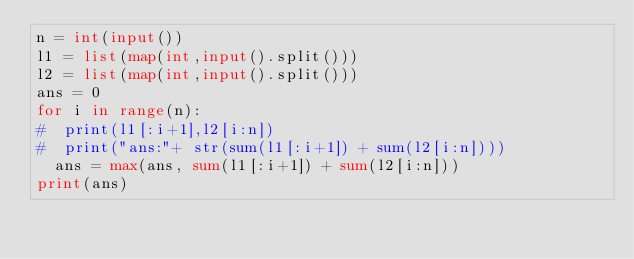Convert code to text. <code><loc_0><loc_0><loc_500><loc_500><_Python_>n = int(input())
l1 = list(map(int,input().split()))
l2 = list(map(int,input().split()))
ans = 0
for i in range(n):
#  print(l1[:i+1],l2[i:n])
#  print("ans:"+ str(sum(l1[:i+1]) + sum(l2[i:n])))
  ans = max(ans, sum(l1[:i+1]) + sum(l2[i:n]))
print(ans)</code> 